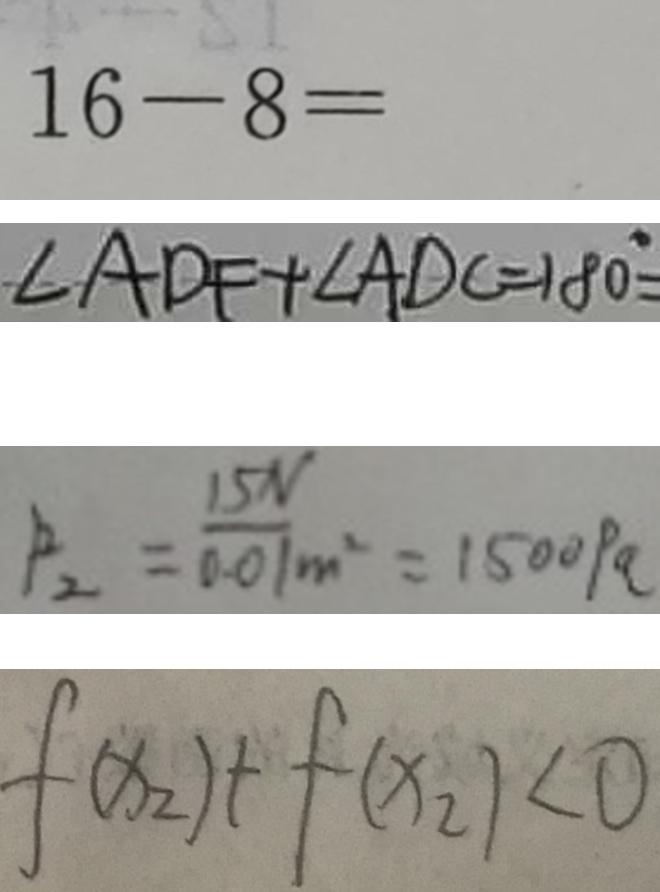Convert formula to latex. <formula><loc_0><loc_0><loc_500><loc_500>1 6 - 8 = 
 \angle A D F + \angle A D C = 1 8 0 ^ { \circ } = 
 P _ { 2 } = \frac { 1 5 N } { 0 . 0 1 } _ { m ^ { 2 } } = 1 5 0 0 P a 
 f ( x _ { 2 } ) + f ( x _ { 2 } ) < 0</formula> 